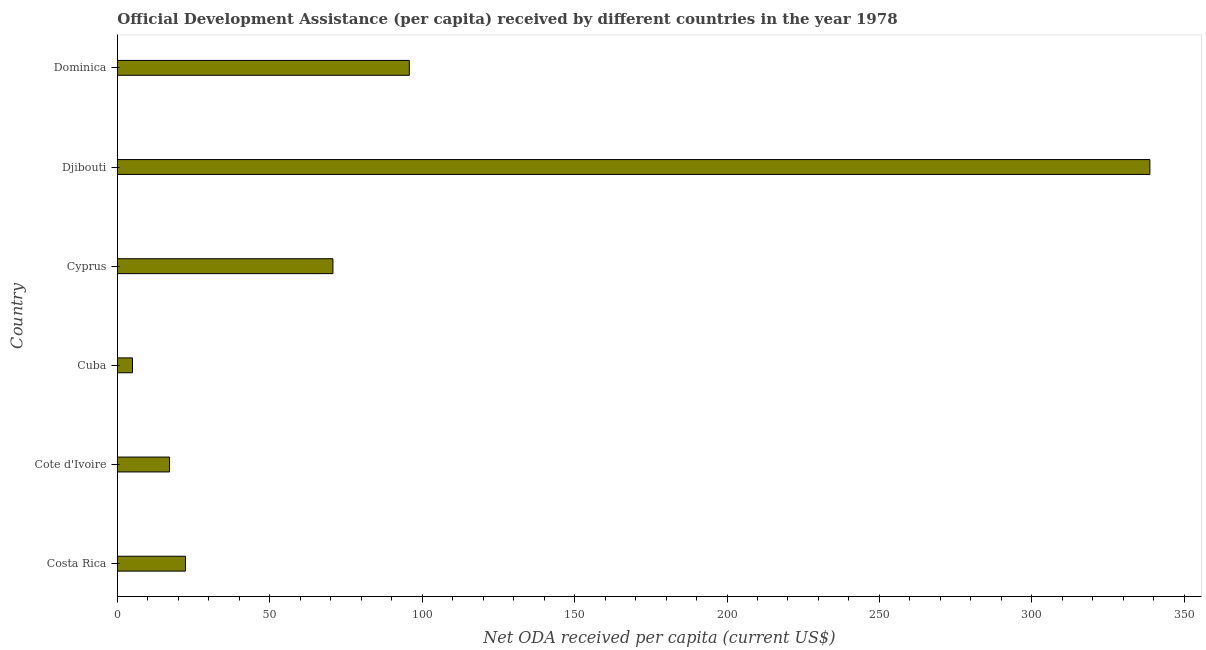Does the graph contain grids?
Ensure brevity in your answer.  No. What is the title of the graph?
Offer a terse response. Official Development Assistance (per capita) received by different countries in the year 1978. What is the label or title of the X-axis?
Provide a succinct answer. Net ODA received per capita (current US$). What is the label or title of the Y-axis?
Offer a very short reply. Country. What is the net oda received per capita in Cyprus?
Provide a short and direct response. 70.72. Across all countries, what is the maximum net oda received per capita?
Provide a succinct answer. 338.73. Across all countries, what is the minimum net oda received per capita?
Provide a succinct answer. 4.94. In which country was the net oda received per capita maximum?
Offer a terse response. Djibouti. In which country was the net oda received per capita minimum?
Ensure brevity in your answer.  Cuba. What is the sum of the net oda received per capita?
Your answer should be compact. 549.6. What is the difference between the net oda received per capita in Cote d'Ivoire and Djibouti?
Keep it short and to the point. -321.61. What is the average net oda received per capita per country?
Ensure brevity in your answer.  91.6. What is the median net oda received per capita?
Your answer should be very brief. 46.52. What is the ratio of the net oda received per capita in Cuba to that in Cyprus?
Give a very brief answer. 0.07. Is the net oda received per capita in Costa Rica less than that in Cyprus?
Ensure brevity in your answer.  Yes. Is the difference between the net oda received per capita in Cote d'Ivoire and Cuba greater than the difference between any two countries?
Ensure brevity in your answer.  No. What is the difference between the highest and the second highest net oda received per capita?
Ensure brevity in your answer.  242.96. What is the difference between the highest and the lowest net oda received per capita?
Offer a terse response. 333.79. Are all the bars in the graph horizontal?
Give a very brief answer. Yes. How many countries are there in the graph?
Your answer should be compact. 6. What is the difference between two consecutive major ticks on the X-axis?
Your response must be concise. 50. Are the values on the major ticks of X-axis written in scientific E-notation?
Your answer should be compact. No. What is the Net ODA received per capita (current US$) of Costa Rica?
Your answer should be compact. 22.33. What is the Net ODA received per capita (current US$) of Cote d'Ivoire?
Your answer should be very brief. 17.11. What is the Net ODA received per capita (current US$) in Cuba?
Offer a terse response. 4.94. What is the Net ODA received per capita (current US$) in Cyprus?
Provide a succinct answer. 70.72. What is the Net ODA received per capita (current US$) of Djibouti?
Give a very brief answer. 338.73. What is the Net ODA received per capita (current US$) of Dominica?
Provide a succinct answer. 95.77. What is the difference between the Net ODA received per capita (current US$) in Costa Rica and Cote d'Ivoire?
Provide a short and direct response. 5.22. What is the difference between the Net ODA received per capita (current US$) in Costa Rica and Cuba?
Your answer should be compact. 17.39. What is the difference between the Net ODA received per capita (current US$) in Costa Rica and Cyprus?
Provide a short and direct response. -48.38. What is the difference between the Net ODA received per capita (current US$) in Costa Rica and Djibouti?
Your answer should be compact. -316.39. What is the difference between the Net ODA received per capita (current US$) in Costa Rica and Dominica?
Ensure brevity in your answer.  -73.44. What is the difference between the Net ODA received per capita (current US$) in Cote d'Ivoire and Cuba?
Your answer should be very brief. 12.17. What is the difference between the Net ODA received per capita (current US$) in Cote d'Ivoire and Cyprus?
Your response must be concise. -53.6. What is the difference between the Net ODA received per capita (current US$) in Cote d'Ivoire and Djibouti?
Make the answer very short. -321.61. What is the difference between the Net ODA received per capita (current US$) in Cote d'Ivoire and Dominica?
Your response must be concise. -78.66. What is the difference between the Net ODA received per capita (current US$) in Cuba and Cyprus?
Offer a very short reply. -65.77. What is the difference between the Net ODA received per capita (current US$) in Cuba and Djibouti?
Keep it short and to the point. -333.79. What is the difference between the Net ODA received per capita (current US$) in Cuba and Dominica?
Provide a short and direct response. -90.83. What is the difference between the Net ODA received per capita (current US$) in Cyprus and Djibouti?
Your answer should be compact. -268.01. What is the difference between the Net ODA received per capita (current US$) in Cyprus and Dominica?
Provide a short and direct response. -25.06. What is the difference between the Net ODA received per capita (current US$) in Djibouti and Dominica?
Provide a succinct answer. 242.96. What is the ratio of the Net ODA received per capita (current US$) in Costa Rica to that in Cote d'Ivoire?
Ensure brevity in your answer.  1.3. What is the ratio of the Net ODA received per capita (current US$) in Costa Rica to that in Cuba?
Offer a terse response. 4.52. What is the ratio of the Net ODA received per capita (current US$) in Costa Rica to that in Cyprus?
Provide a short and direct response. 0.32. What is the ratio of the Net ODA received per capita (current US$) in Costa Rica to that in Djibouti?
Your answer should be compact. 0.07. What is the ratio of the Net ODA received per capita (current US$) in Costa Rica to that in Dominica?
Ensure brevity in your answer.  0.23. What is the ratio of the Net ODA received per capita (current US$) in Cote d'Ivoire to that in Cuba?
Provide a short and direct response. 3.46. What is the ratio of the Net ODA received per capita (current US$) in Cote d'Ivoire to that in Cyprus?
Make the answer very short. 0.24. What is the ratio of the Net ODA received per capita (current US$) in Cote d'Ivoire to that in Djibouti?
Provide a succinct answer. 0.05. What is the ratio of the Net ODA received per capita (current US$) in Cote d'Ivoire to that in Dominica?
Make the answer very short. 0.18. What is the ratio of the Net ODA received per capita (current US$) in Cuba to that in Cyprus?
Make the answer very short. 0.07. What is the ratio of the Net ODA received per capita (current US$) in Cuba to that in Djibouti?
Your answer should be very brief. 0.01. What is the ratio of the Net ODA received per capita (current US$) in Cuba to that in Dominica?
Give a very brief answer. 0.05. What is the ratio of the Net ODA received per capita (current US$) in Cyprus to that in Djibouti?
Make the answer very short. 0.21. What is the ratio of the Net ODA received per capita (current US$) in Cyprus to that in Dominica?
Keep it short and to the point. 0.74. What is the ratio of the Net ODA received per capita (current US$) in Djibouti to that in Dominica?
Ensure brevity in your answer.  3.54. 